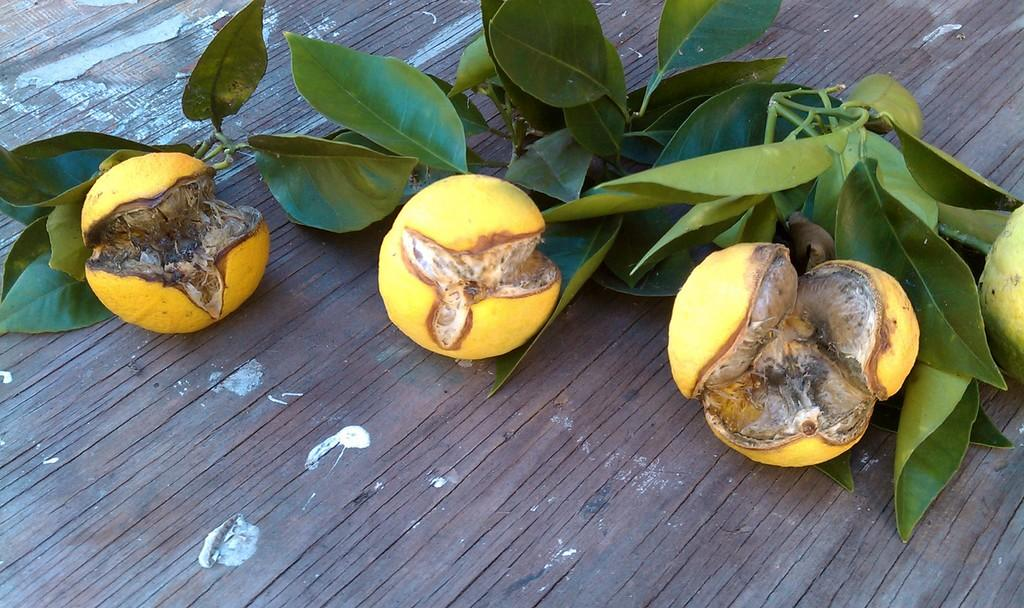What type of food items can be seen in the image? There are fruits in the image. What else is present in the image besides the fruits? There are leaves in the image. On what surface are the fruits and leaves placed? The fruits and leaves are on wood. What type of jam is being prepared on the wood in the image? There is no jam or preparation of jam visible in the image; it only features fruits and leaves on wood. 